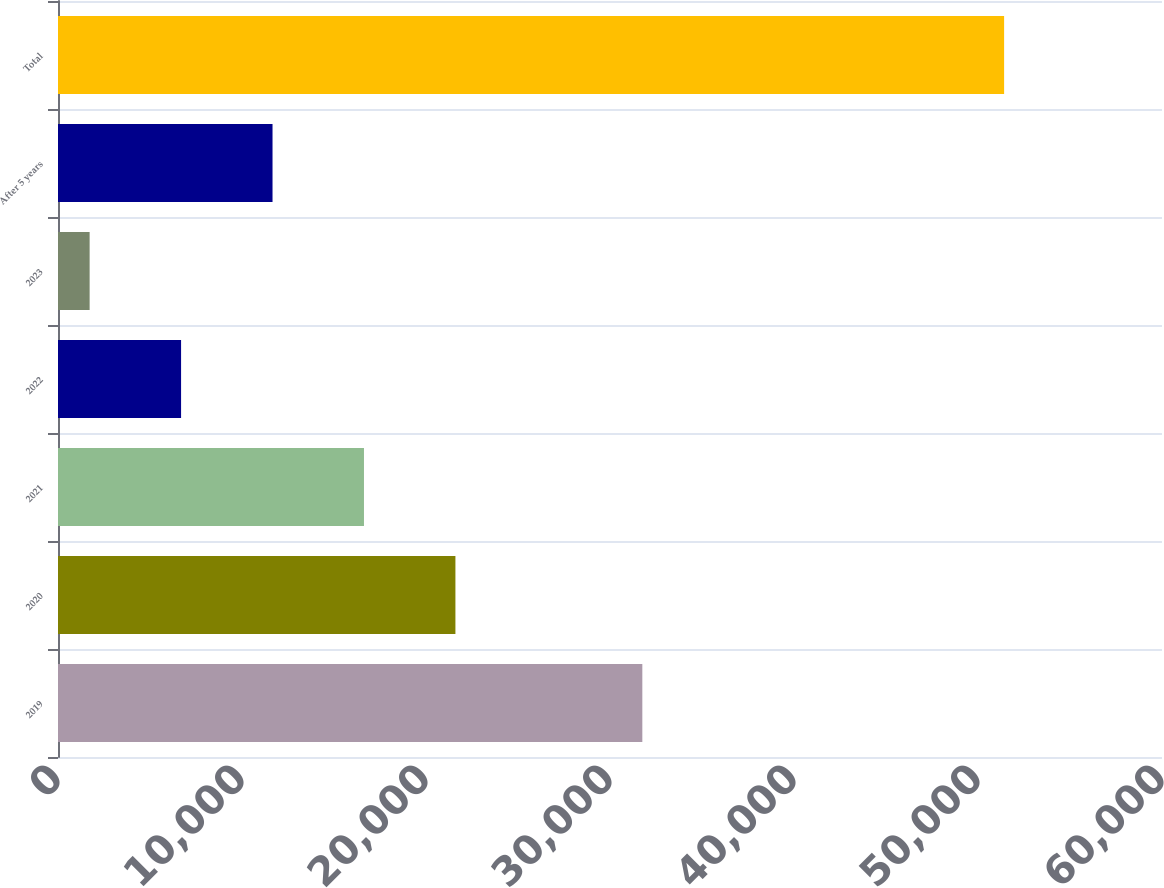Convert chart. <chart><loc_0><loc_0><loc_500><loc_500><bar_chart><fcel>2019<fcel>2020<fcel>2021<fcel>2022<fcel>2023<fcel>After 5 years<fcel>Total<nl><fcel>31757<fcel>21599<fcel>16629<fcel>6689<fcel>1719<fcel>11659<fcel>51419<nl></chart> 